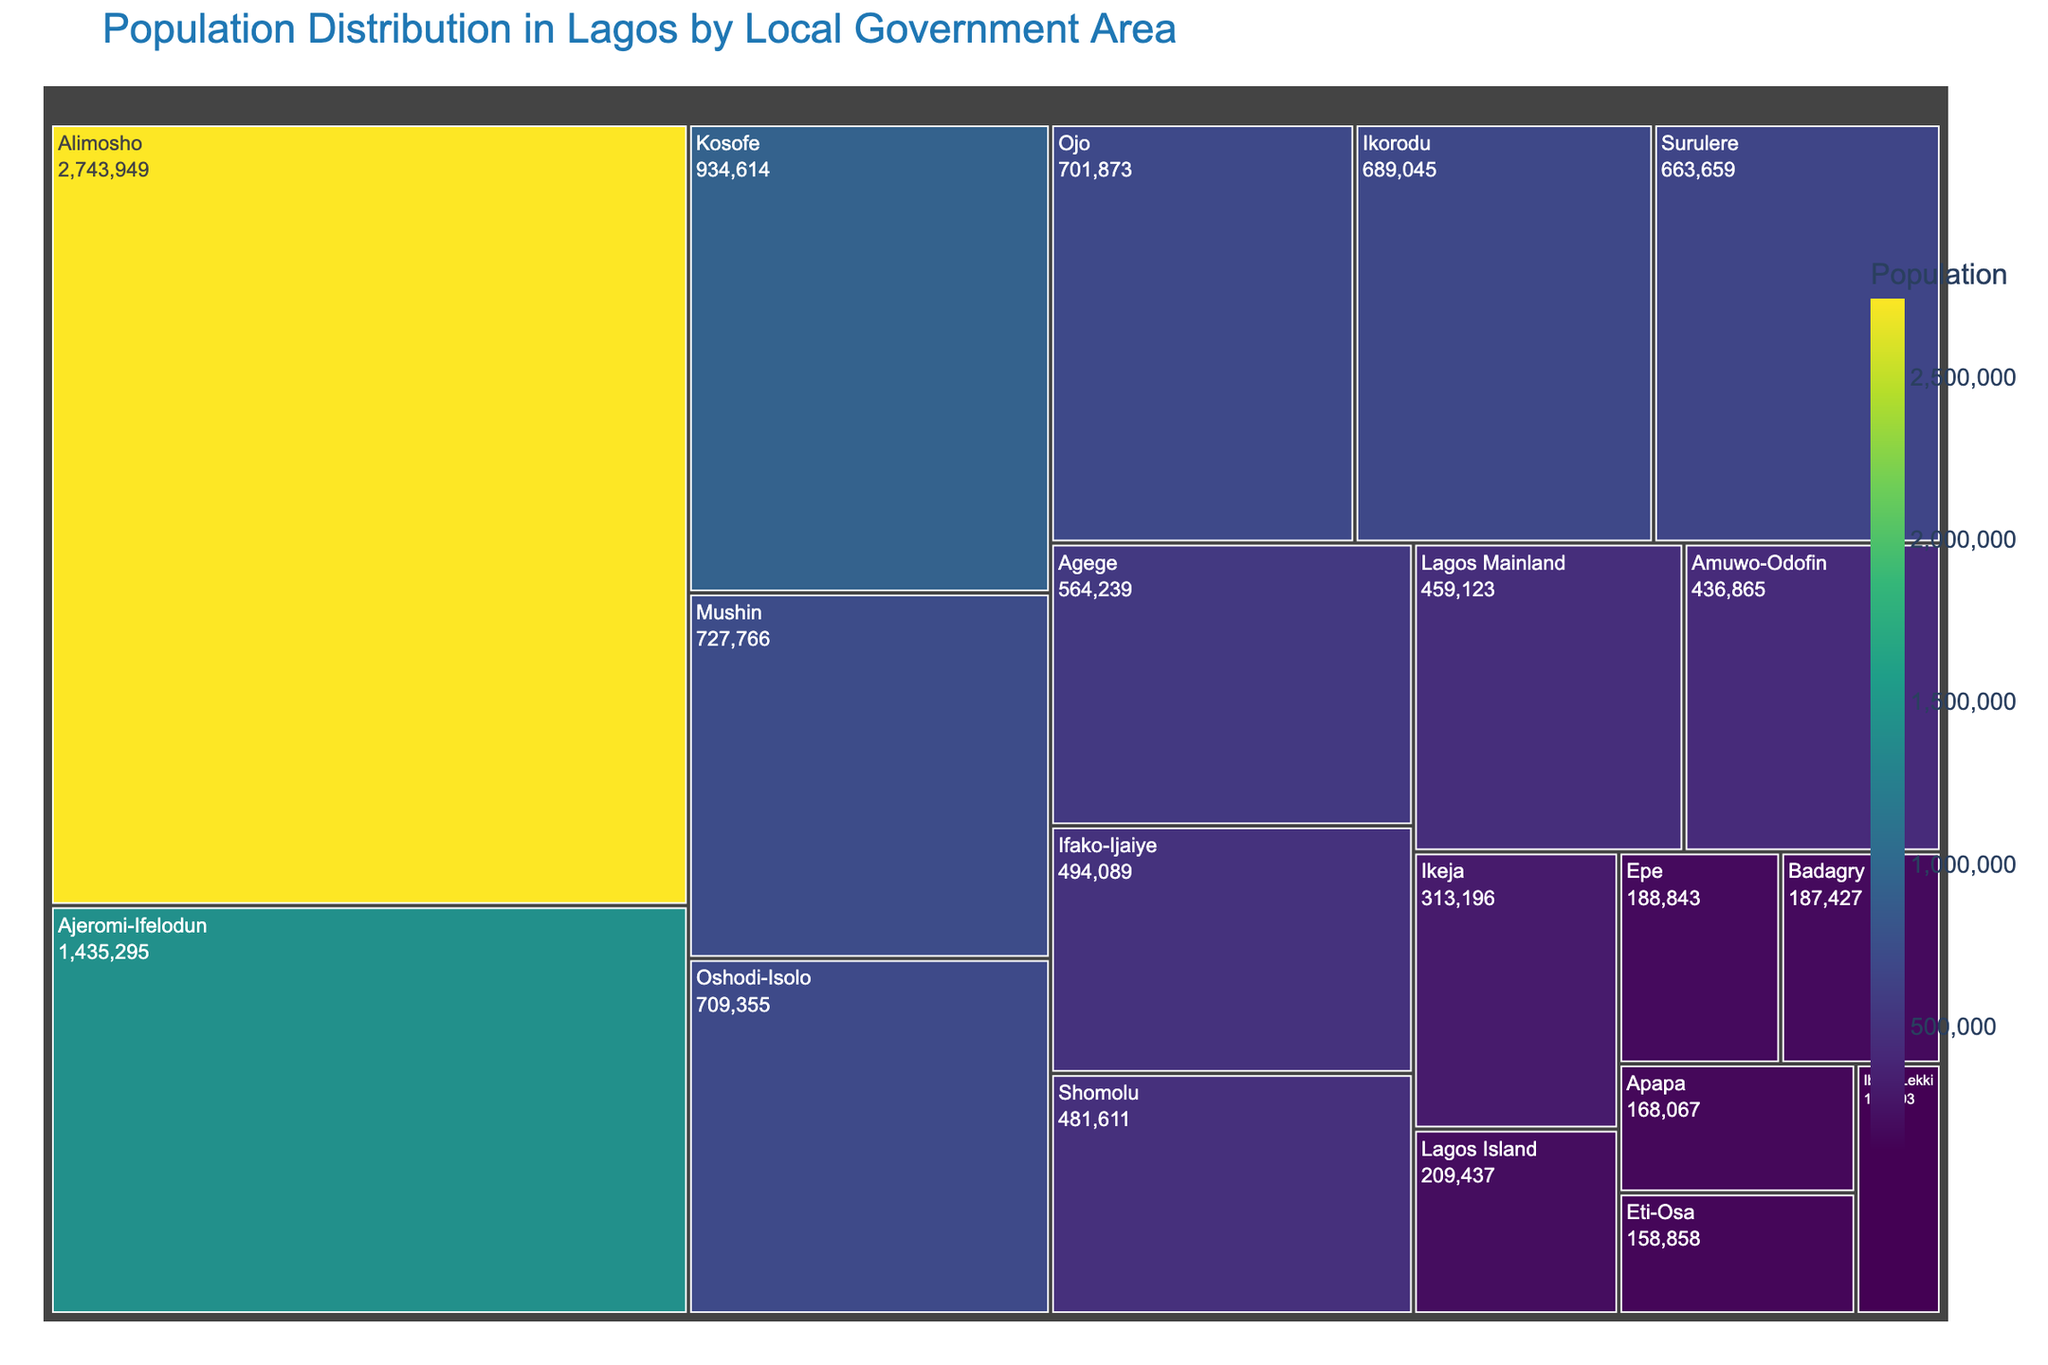What is the title of the treemap? The title of a figure or chart is usually positioned at the top and clearly labels what the figure represents.
Answer: Population Distribution in Lagos by Local Government Area Which Local Government Area has the highest population? By looking at the size of the treemap boxes, we can identify Alimosho as the largest box, indicating it has the highest population.
Answer: Alimosho What is the total population of Lagos according to the treemap? To find the total population, sum the population of all Local Government Areas shown in the treemap.
Answer: 14,367,004 How does the population of Ikorodu compare to that of Agege? Compare the sizes of the relevant boxes in the figure. Ikorodu's box is slightly larger than Agege's, indicating Ikorodu has a greater population.
Answer: Ikorodu has a larger population than Agege What is the color scale used in the treemap? Observing the color gradient within the treemap, the more intense colors, like dark purple, represent higher populations while the lighter colors represent lower populations. The color scale is 'Viridis'.
Answer: Viridis Which Local Government Areas are closest in population size to each other? By examining the treemap, Agege and Ifako-Ijaiye have similar-sized boxes and close population values.
Answer: Agege and Ifako-Ijaiye List all Local Government Areas with a population greater than 1 million. Identify boxes that appear larger and have labels indicating more than 1 million population: Alimosho, Ajeromi-Ifelodun.
Answer: Alimosho, Ajeromi-Ifelodun What is the combined population of Mushin and Oshodi-Isolo? Add the populations of Mushin (727,766) and Oshodi-Isolo (709,355). 727,766 + 709,355 = 1,437,121.
Answer: 1,437,121 How does the population of Lagos Island compare to that of Lagos Mainland? The box for Lagos Mainland is significantly larger than that for Lagos Island, meaning Lagos Mainland has a higher population.
Answer: Lagos Mainland has a higher population than Lagos Island Which area has the smallest population, and what is it? The smallest box in the treemap corresponds to Ibeju-Lekki, representing the smallest population.
Answer: Ibeju-Lekki, 117,793 